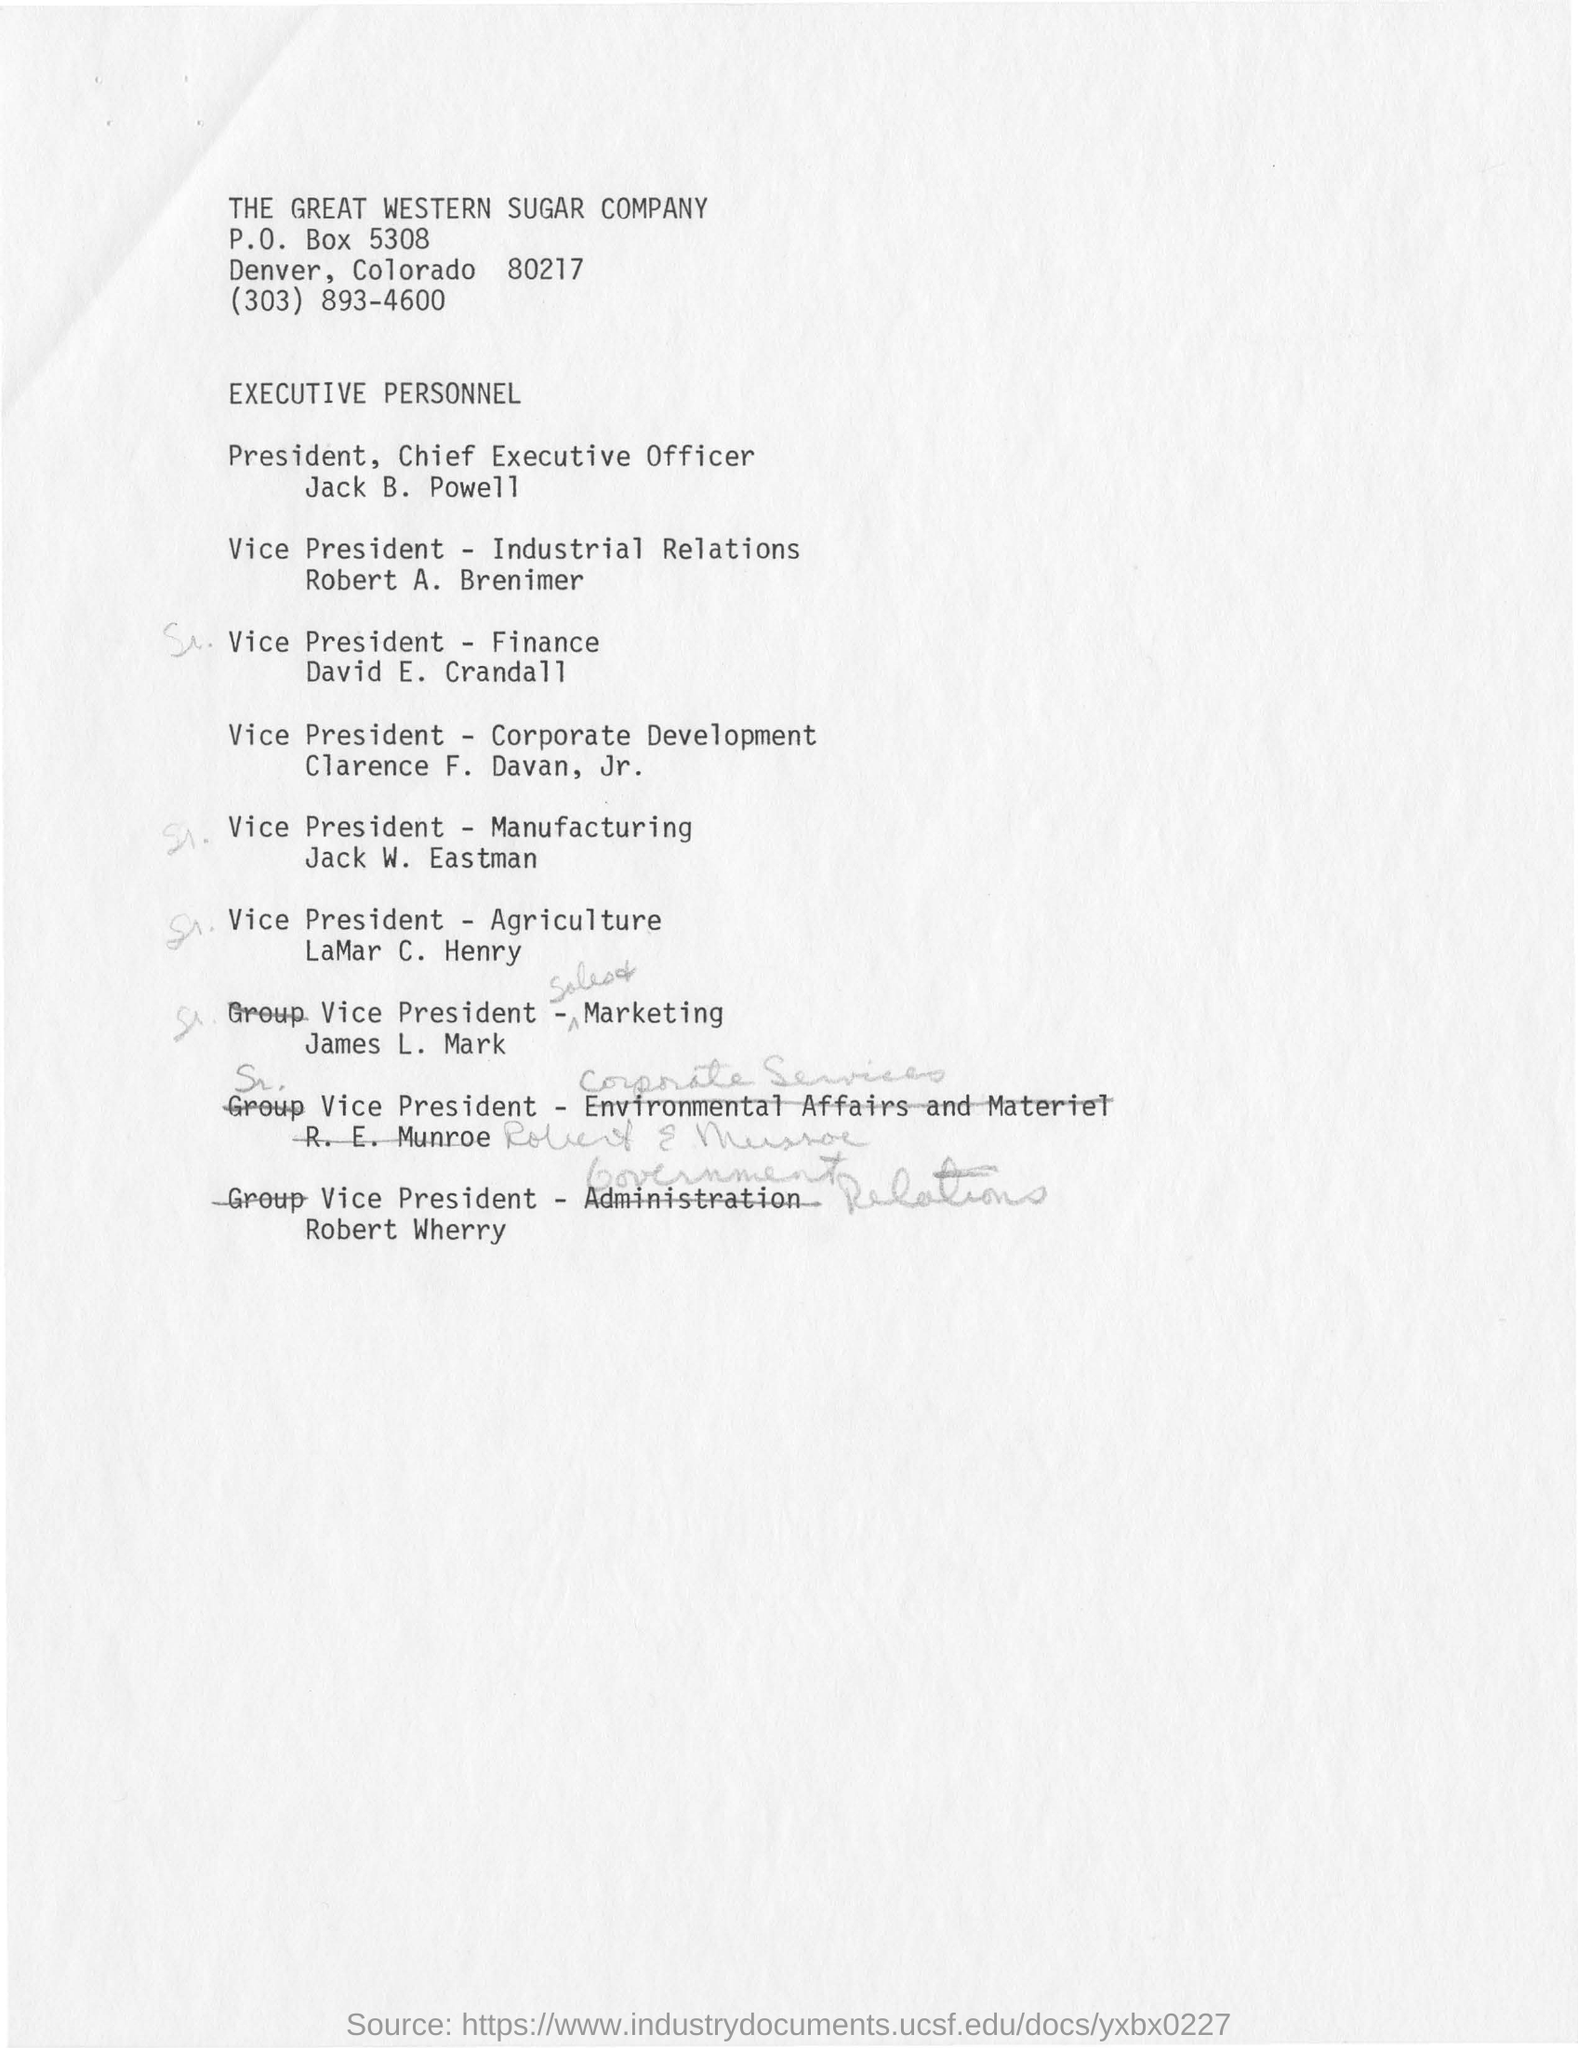What is the sugar company name?
Provide a short and direct response. The great western sugar company. Who is the vice president of finance?
Provide a short and direct response. David e. crandall. Who is the vice President of industrial relations?
Your answer should be very brief. Robert A. Brenimer. 